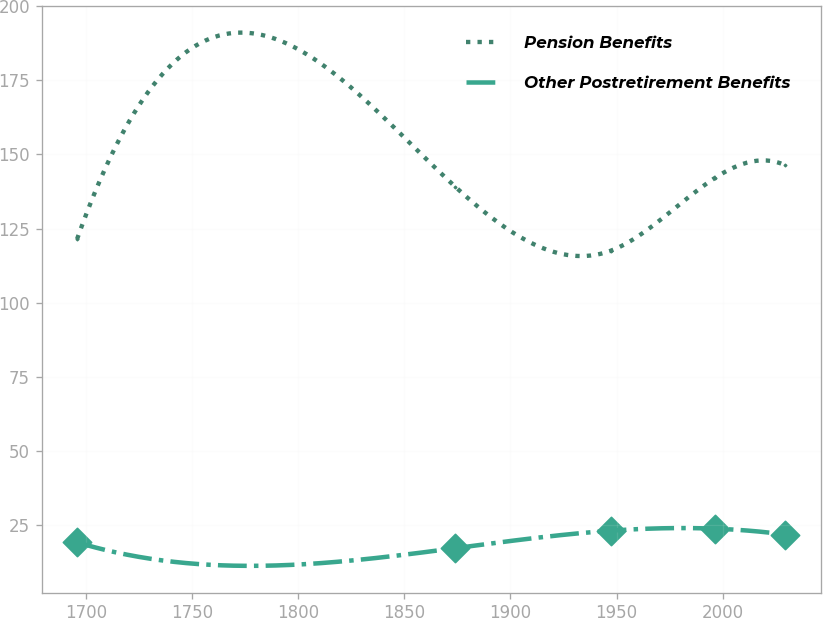<chart> <loc_0><loc_0><loc_500><loc_500><line_chart><ecel><fcel>Pension Benefits<fcel>Other Postretirement Benefits<nl><fcel>1695.91<fcel>121.43<fcel>19.16<nl><fcel>1873.92<fcel>139.17<fcel>17.18<nl><fcel>1947.21<fcel>117.5<fcel>23.09<nl><fcel>1996.33<fcel>142.06<fcel>23.77<nl><fcel>2029.41<fcel>146.36<fcel>21.79<nl></chart> 